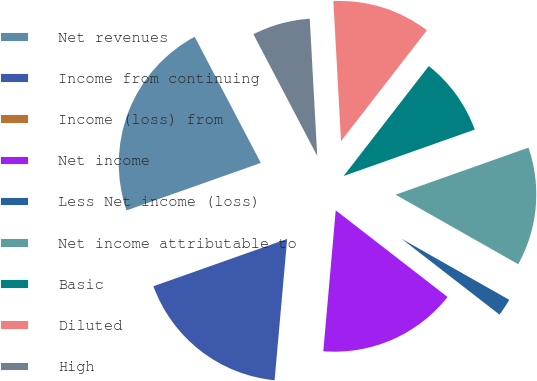Convert chart to OTSL. <chart><loc_0><loc_0><loc_500><loc_500><pie_chart><fcel>Net revenues<fcel>Income from continuing<fcel>Income (loss) from<fcel>Net income<fcel>Less Net income (loss)<fcel>Net income attributable to<fcel>Basic<fcel>Diluted<fcel>High<nl><fcel>22.72%<fcel>18.18%<fcel>0.01%<fcel>15.91%<fcel>2.28%<fcel>13.63%<fcel>9.09%<fcel>11.36%<fcel>6.82%<nl></chart> 